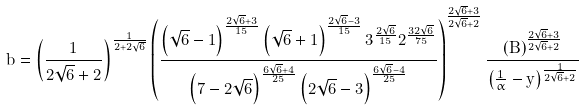Convert formula to latex. <formula><loc_0><loc_0><loc_500><loc_500>b = \left ( \frac { 1 } { 2 \sqrt { 6 } + 2 } \right ) ^ { \frac { 1 } { 2 + 2 \sqrt { 6 } } } \left ( \frac { \left ( \sqrt { 6 } - 1 \right ) ^ { \frac { 2 \sqrt { 6 } + 3 } { 1 5 } } \left ( \sqrt { 6 } + 1 \right ) ^ { \frac { 2 \sqrt { 6 } - 3 } { 1 5 } } 3 ^ { \frac { 2 \sqrt { 6 } } { 1 5 } } 2 ^ { \frac { 3 2 \sqrt { 6 } } { 7 5 } } } { \left ( 7 - 2 \sqrt { 6 } \right ) ^ { \frac { 6 \sqrt { 6 } + 4 } { 2 5 } } \left ( 2 \sqrt { 6 } - 3 \right ) ^ { \frac { 6 \sqrt { 6 } - 4 } { 2 5 } } } \right ) ^ { \frac { 2 \sqrt { 6 } + 3 } { 2 \sqrt { 6 } + 2 } } \frac { \left ( B \right ) ^ { \frac { 2 \sqrt { 6 } + 3 } { 2 \sqrt { 6 } + 2 } } } { \left ( \frac { 1 } { \alpha } - y \right ) ^ { \frac { 1 } { 2 \sqrt { 6 } + 2 } } }</formula> 